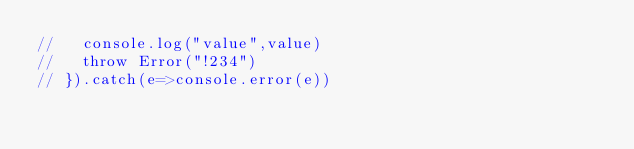Convert code to text. <code><loc_0><loc_0><loc_500><loc_500><_JavaScript_>//   console.log("value",value)
//   throw Error("!234")
// }).catch(e=>console.error(e))</code> 